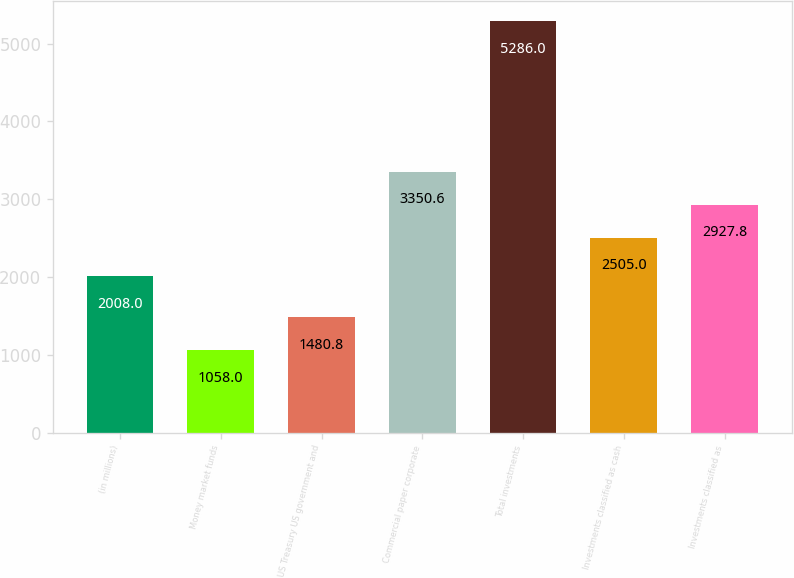Convert chart. <chart><loc_0><loc_0><loc_500><loc_500><bar_chart><fcel>(in millions)<fcel>Money market funds<fcel>US Treasury US government and<fcel>Commercial paper corporate<fcel>Total investments<fcel>Investments classified as cash<fcel>Investments classified as<nl><fcel>2008<fcel>1058<fcel>1480.8<fcel>3350.6<fcel>5286<fcel>2505<fcel>2927.8<nl></chart> 